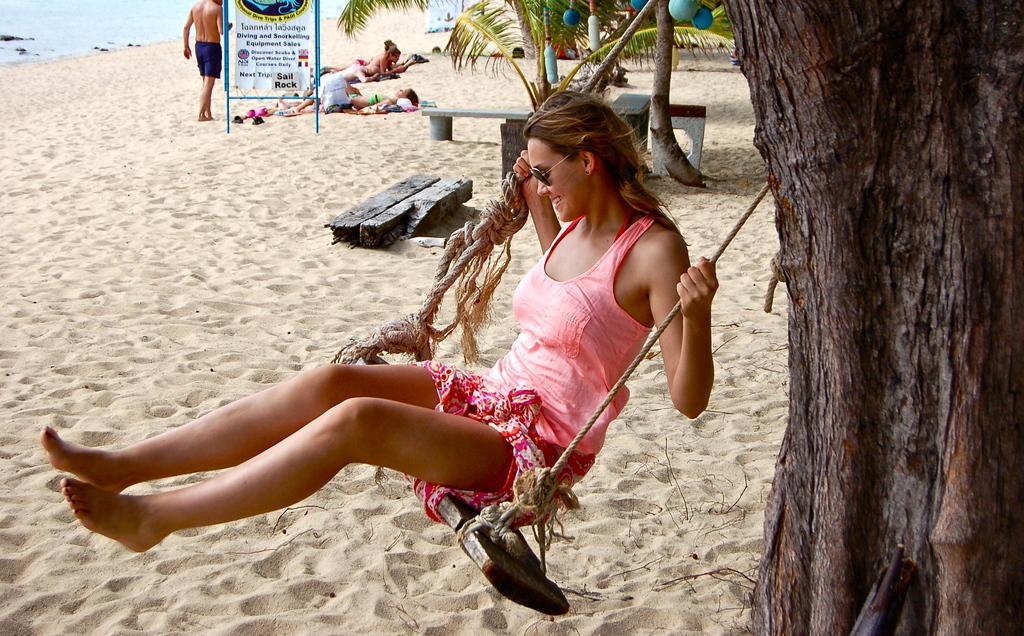In one or two sentences, can you explain what this image depicts? In the foreground of this image, there is a woman sitting on a swing and on the right, there is the tree trunk. In the background, there is sand, few wooden poles, benches, trees and persons lying and walking on the sand. On the top, there is the water. 